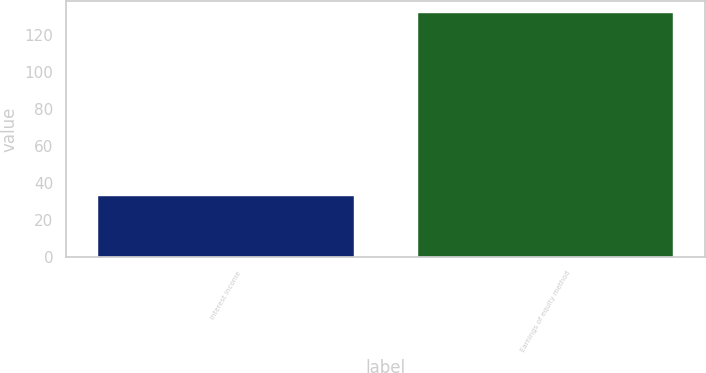Convert chart to OTSL. <chart><loc_0><loc_0><loc_500><loc_500><bar_chart><fcel>Interest income<fcel>Earnings of equity method<nl><fcel>33<fcel>132<nl></chart> 